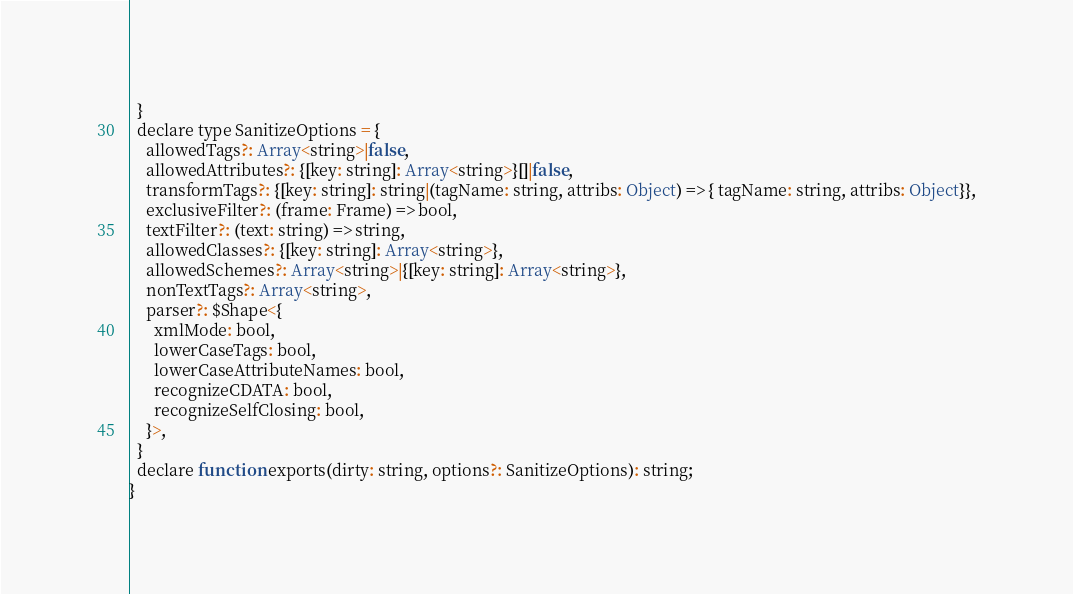<code> <loc_0><loc_0><loc_500><loc_500><_JavaScript_>  }
  declare type SanitizeOptions = {
    allowedTags?: Array<string>|false,
    allowedAttributes?: {[key: string]: Array<string>}[]|false,
    transformTags?: {[key: string]: string|(tagName: string, attribs: Object) => { tagName: string, attribs: Object}},
    exclusiveFilter?: (frame: Frame) => bool,
    textFilter?: (text: string) => string,
    allowedClasses?: {[key: string]: Array<string>},
    allowedSchemes?: Array<string>|{[key: string]: Array<string>},
    nonTextTags?: Array<string>,
    parser?: $Shape<{
      xmlMode: bool,
      lowerCaseTags: bool,
      lowerCaseAttributeNames: bool,
      recognizeCDATA: bool,
      recognizeSelfClosing: bool,
    }>,
  }
  declare function exports(dirty: string, options?: SanitizeOptions): string;
}
</code> 